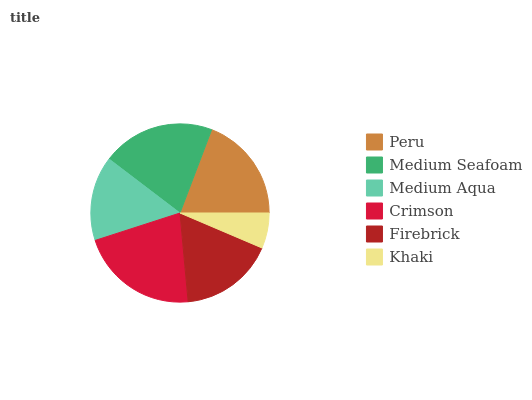Is Khaki the minimum?
Answer yes or no. Yes. Is Crimson the maximum?
Answer yes or no. Yes. Is Medium Seafoam the minimum?
Answer yes or no. No. Is Medium Seafoam the maximum?
Answer yes or no. No. Is Medium Seafoam greater than Peru?
Answer yes or no. Yes. Is Peru less than Medium Seafoam?
Answer yes or no. Yes. Is Peru greater than Medium Seafoam?
Answer yes or no. No. Is Medium Seafoam less than Peru?
Answer yes or no. No. Is Peru the high median?
Answer yes or no. Yes. Is Firebrick the low median?
Answer yes or no. Yes. Is Firebrick the high median?
Answer yes or no. No. Is Medium Seafoam the low median?
Answer yes or no. No. 